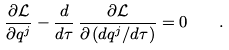<formula> <loc_0><loc_0><loc_500><loc_500>\frac { \partial \mathcal { L } } { \partial q ^ { j } } - \frac { d } { d \tau } \, \frac { \partial \mathcal { L } } { \partial \, ( d q ^ { j } / d \tau ) } = 0 \quad .</formula> 